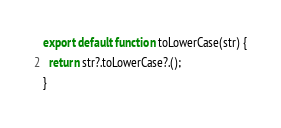Convert code to text. <code><loc_0><loc_0><loc_500><loc_500><_JavaScript_>export default function toLowerCase(str) {
  return str?.toLowerCase?.();
}
</code> 